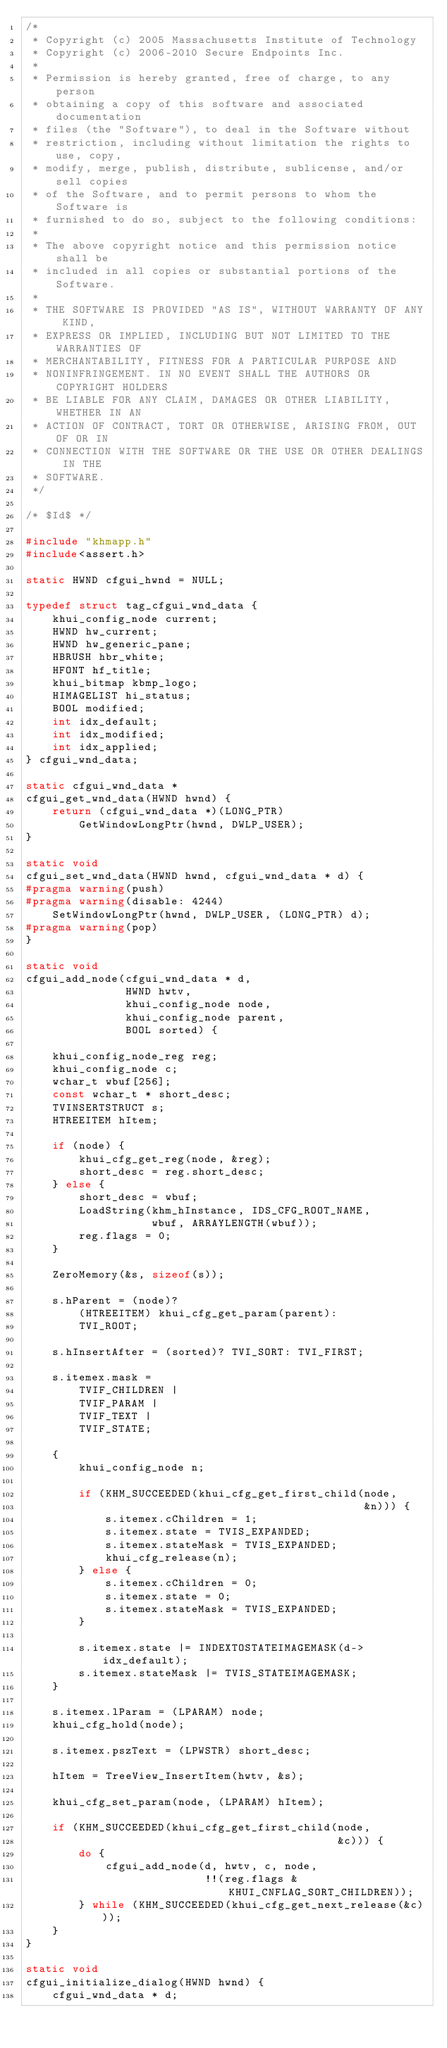Convert code to text. <code><loc_0><loc_0><loc_500><loc_500><_C_>/*
 * Copyright (c) 2005 Massachusetts Institute of Technology
 * Copyright (c) 2006-2010 Secure Endpoints Inc.
 *
 * Permission is hereby granted, free of charge, to any person
 * obtaining a copy of this software and associated documentation
 * files (the "Software"), to deal in the Software without
 * restriction, including without limitation the rights to use, copy,
 * modify, merge, publish, distribute, sublicense, and/or sell copies
 * of the Software, and to permit persons to whom the Software is
 * furnished to do so, subject to the following conditions:
 *
 * The above copyright notice and this permission notice shall be
 * included in all copies or substantial portions of the Software.
 *
 * THE SOFTWARE IS PROVIDED "AS IS", WITHOUT WARRANTY OF ANY KIND,
 * EXPRESS OR IMPLIED, INCLUDING BUT NOT LIMITED TO THE WARRANTIES OF
 * MERCHANTABILITY, FITNESS FOR A PARTICULAR PURPOSE AND
 * NONINFRINGEMENT. IN NO EVENT SHALL THE AUTHORS OR COPYRIGHT HOLDERS
 * BE LIABLE FOR ANY CLAIM, DAMAGES OR OTHER LIABILITY, WHETHER IN AN
 * ACTION OF CONTRACT, TORT OR OTHERWISE, ARISING FROM, OUT OF OR IN
 * CONNECTION WITH THE SOFTWARE OR THE USE OR OTHER DEALINGS IN THE
 * SOFTWARE.
 */

/* $Id$ */

#include "khmapp.h"
#include<assert.h>

static HWND cfgui_hwnd = NULL;

typedef struct tag_cfgui_wnd_data {
    khui_config_node current;
    HWND hw_current;
    HWND hw_generic_pane;
    HBRUSH hbr_white;
    HFONT hf_title;
    khui_bitmap kbmp_logo;
    HIMAGELIST hi_status;
    BOOL modified;
    int idx_default;
    int idx_modified;
    int idx_applied;
} cfgui_wnd_data;

static cfgui_wnd_data *
cfgui_get_wnd_data(HWND hwnd) {
    return (cfgui_wnd_data *)(LONG_PTR)
        GetWindowLongPtr(hwnd, DWLP_USER);
}

static void
cfgui_set_wnd_data(HWND hwnd, cfgui_wnd_data * d) {
#pragma warning(push)
#pragma warning(disable: 4244)
    SetWindowLongPtr(hwnd, DWLP_USER, (LONG_PTR) d);
#pragma warning(pop)
}

static void
cfgui_add_node(cfgui_wnd_data * d,
               HWND hwtv,
               khui_config_node node,
               khui_config_node parent,
               BOOL sorted) {

    khui_config_node_reg reg;
    khui_config_node c;
    wchar_t wbuf[256];
    const wchar_t * short_desc;
    TVINSERTSTRUCT s;
    HTREEITEM hItem;

    if (node) {
        khui_cfg_get_reg(node, &reg);
        short_desc = reg.short_desc;
    } else {
        short_desc = wbuf;
        LoadString(khm_hInstance, IDS_CFG_ROOT_NAME,
                   wbuf, ARRAYLENGTH(wbuf));
        reg.flags = 0;
    }

    ZeroMemory(&s, sizeof(s));

    s.hParent = (node)?
        (HTREEITEM) khui_cfg_get_param(parent):
        TVI_ROOT;

    s.hInsertAfter = (sorted)? TVI_SORT: TVI_FIRST;

    s.itemex.mask =
        TVIF_CHILDREN |
        TVIF_PARAM |
        TVIF_TEXT |
        TVIF_STATE;

    {
        khui_config_node n;

        if (KHM_SUCCEEDED(khui_cfg_get_first_child(node,
                                                   &n))) {
            s.itemex.cChildren = 1;
            s.itemex.state = TVIS_EXPANDED;
            s.itemex.stateMask = TVIS_EXPANDED;
            khui_cfg_release(n);
        } else {
            s.itemex.cChildren = 0;
            s.itemex.state = 0;
            s.itemex.stateMask = TVIS_EXPANDED;
        }

        s.itemex.state |= INDEXTOSTATEIMAGEMASK(d->idx_default);
        s.itemex.stateMask |= TVIS_STATEIMAGEMASK;
    }

    s.itemex.lParam = (LPARAM) node;
    khui_cfg_hold(node);

    s.itemex.pszText = (LPWSTR) short_desc;

    hItem = TreeView_InsertItem(hwtv, &s);

    khui_cfg_set_param(node, (LPARAM) hItem);

    if (KHM_SUCCEEDED(khui_cfg_get_first_child(node,
                                               &c))) {
        do {
            cfgui_add_node(d, hwtv, c, node,
                           !!(reg.flags & KHUI_CNFLAG_SORT_CHILDREN));
        } while (KHM_SUCCEEDED(khui_cfg_get_next_release(&c)));
    }
}

static void
cfgui_initialize_dialog(HWND hwnd) {
    cfgui_wnd_data * d;</code> 